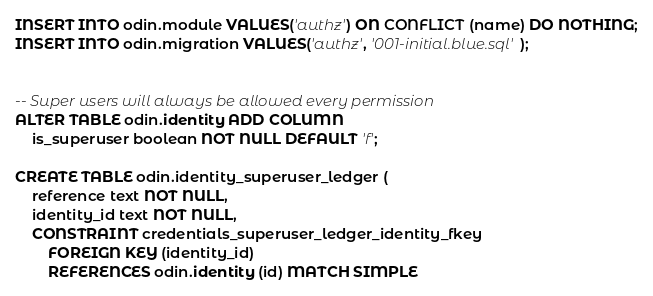Convert code to text. <code><loc_0><loc_0><loc_500><loc_500><_SQL_>INSERT INTO odin.module VALUES('authz') ON CONFLICT (name) DO NOTHING;
INSERT INTO odin.migration VALUES('authz', '001-initial.blue.sql');


-- Super users will always be allowed every permission
ALTER TABLE odin.identity ADD COLUMN
    is_superuser boolean NOT NULL DEFAULT 'f';

CREATE TABLE odin.identity_superuser_ledger (
    reference text NOT NULL,
    identity_id text NOT NULL,
    CONSTRAINT credentials_superuser_ledger_identity_fkey
        FOREIGN KEY (identity_id)
        REFERENCES odin.identity (id) MATCH SIMPLE</code> 